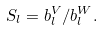Convert formula to latex. <formula><loc_0><loc_0><loc_500><loc_500>S _ { l } = b _ { l } ^ { V } / b _ { l } ^ { W } .</formula> 